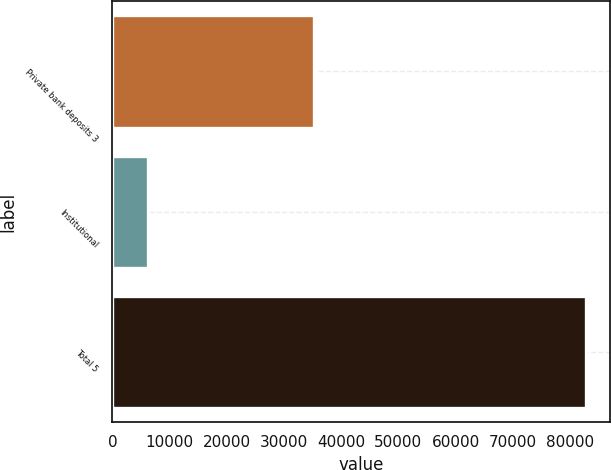Convert chart to OTSL. <chart><loc_0><loc_0><loc_500><loc_500><bar_chart><fcel>Private bank deposits 3<fcel>Institutional<fcel>Total 5<nl><fcel>35199<fcel>6210<fcel>82880<nl></chart> 